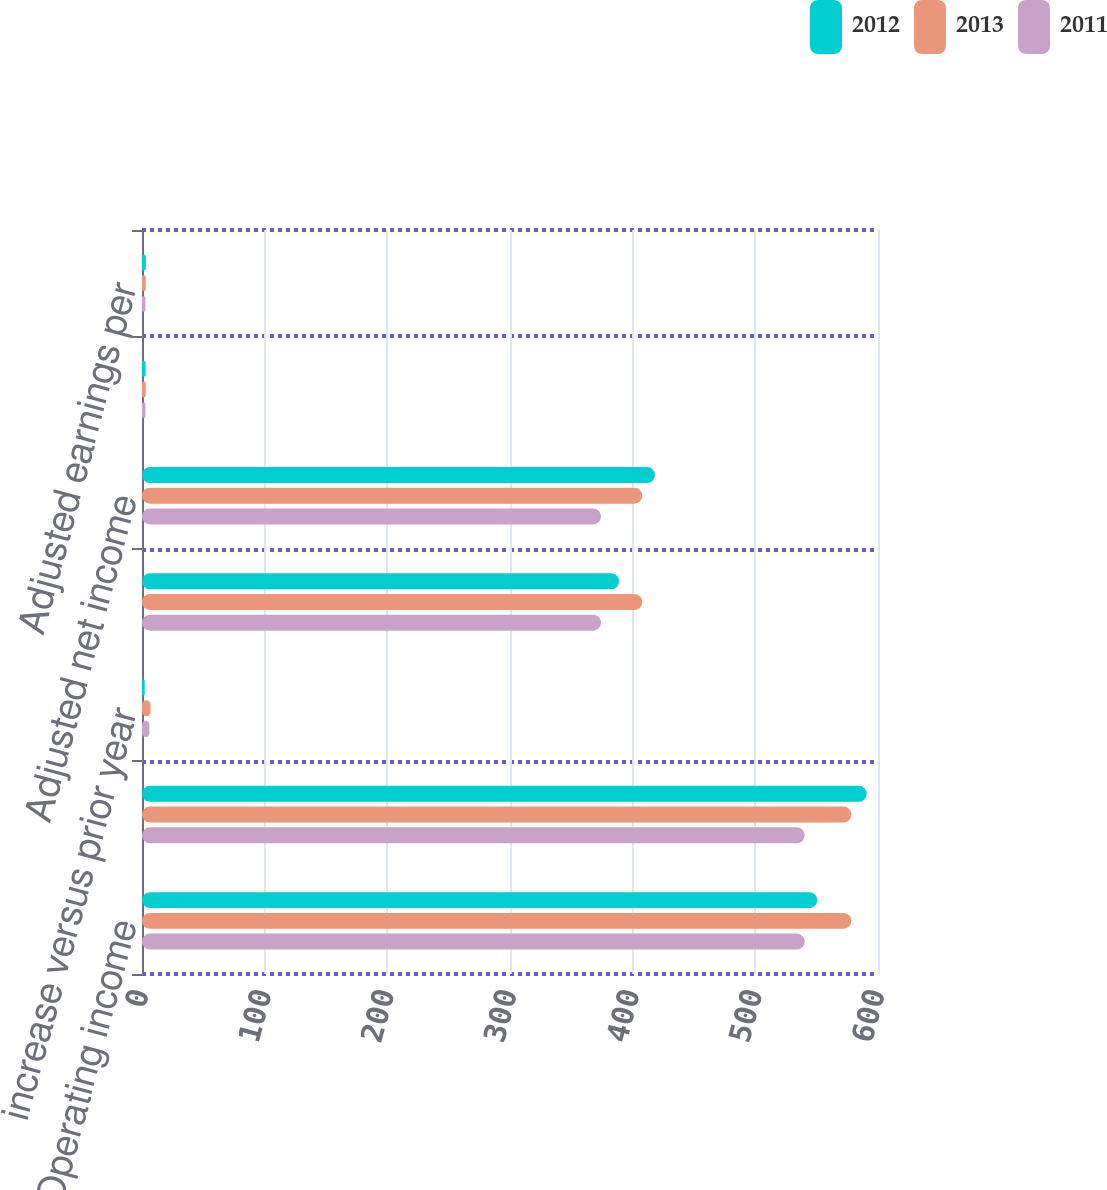Convert chart. <chart><loc_0><loc_0><loc_500><loc_500><stacked_bar_chart><ecel><fcel>Operating income<fcel>Adjusted operating income<fcel>increase versus prior year<fcel>Net income<fcel>Adjusted net income<fcel>Earnings per share-diluted<fcel>Adjusted earnings per<nl><fcel>2012<fcel>550.5<fcel>590.8<fcel>2.2<fcel>389<fcel>418.2<fcel>2.91<fcel>3.13<nl><fcel>2013<fcel>578.3<fcel>578.3<fcel>7<fcel>407.8<fcel>407.8<fcel>3.04<fcel>3.04<nl><fcel>2011<fcel>540.3<fcel>540.3<fcel>6<fcel>374.2<fcel>374.2<fcel>2.79<fcel>2.79<nl></chart> 